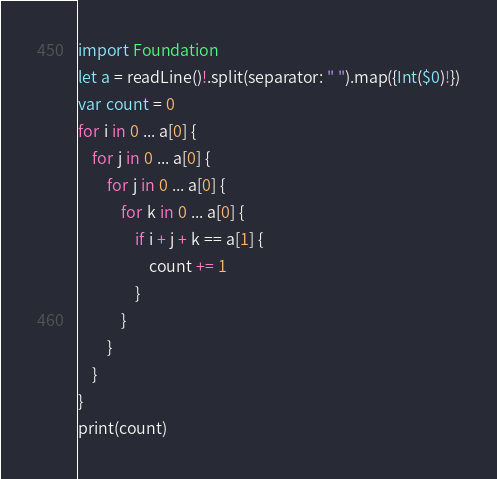Convert code to text. <code><loc_0><loc_0><loc_500><loc_500><_Swift_>import Foundation
let a = readLine()!.split(separator: " ").map({Int($0)!})
var count = 0
for i in 0 ... a[0] {
    for j in 0 ... a[0] {
        for j in 0 ... a[0] {
            for k in 0 ... a[0] {
                if i + j + k == a[1] {
                    count += 1
                }
            }
        }
    }
}
print(count)</code> 